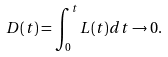<formula> <loc_0><loc_0><loc_500><loc_500>D ( t ) = \int _ { 0 } ^ { t } L ( t ) d t \rightarrow 0 .</formula> 